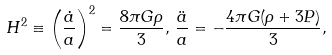<formula> <loc_0><loc_0><loc_500><loc_500>H ^ { 2 } \equiv \left ( \frac { \dot { a } } { a } \right ) ^ { 2 } = \frac { 8 \pi G \rho } { 3 } , \, \frac { \ddot { a } } { a } = - \frac { 4 \pi G ( \rho + 3 P ) } { 3 } ,</formula> 